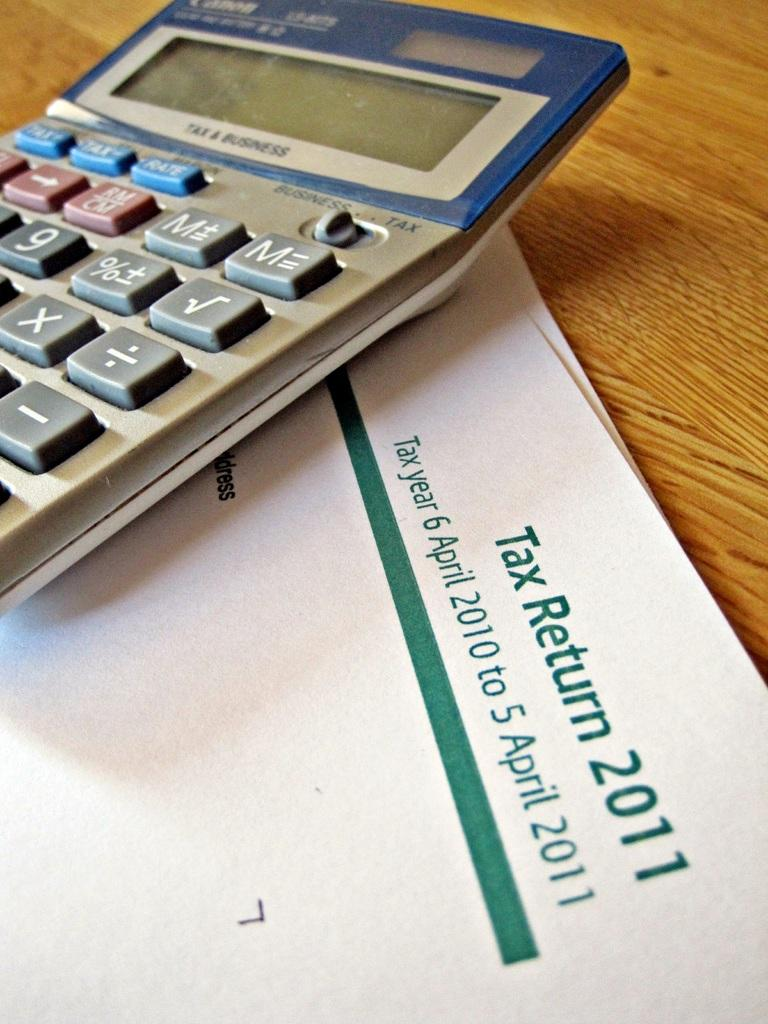What objects are present on the table in the image? There are papers and a calculator on the table in the image. What might be used for performing calculations in the image? A calculator is present in the image for performing calculations. What type of objects are the papers in the image? The papers in the image are likely documents or sheets of paper. What type of collar can be seen on the yard in the image? There is no collar or yard present in the image; it features papers and a calculator on a table. 